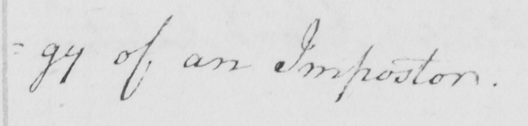Please provide the text content of this handwritten line. -y of an Impostor . 